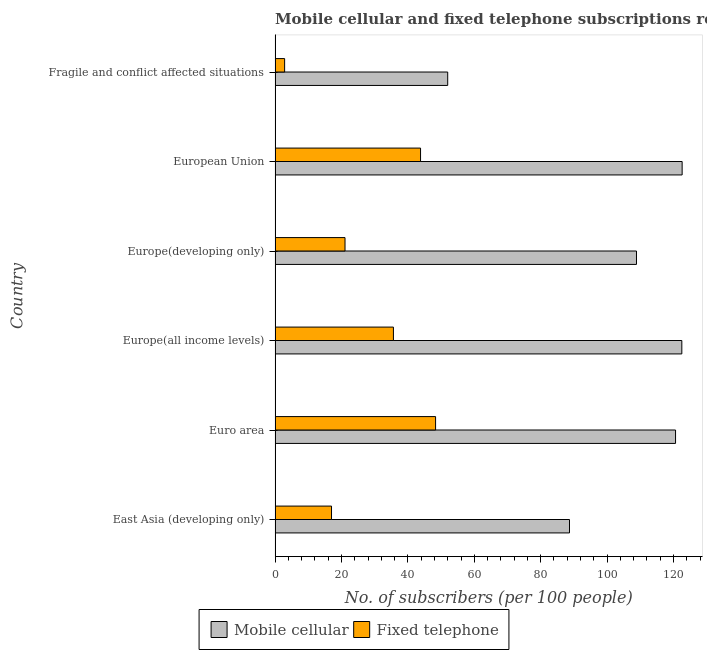Are the number of bars per tick equal to the number of legend labels?
Offer a terse response. Yes. How many bars are there on the 1st tick from the top?
Offer a very short reply. 2. What is the label of the 1st group of bars from the top?
Offer a terse response. Fragile and conflict affected situations. In how many cases, is the number of bars for a given country not equal to the number of legend labels?
Offer a very short reply. 0. What is the number of fixed telephone subscribers in Europe(developing only)?
Your answer should be very brief. 21.07. Across all countries, what is the maximum number of mobile cellular subscribers?
Offer a terse response. 122.61. Across all countries, what is the minimum number of mobile cellular subscribers?
Provide a short and direct response. 51.99. In which country was the number of mobile cellular subscribers minimum?
Your response must be concise. Fragile and conflict affected situations. What is the total number of fixed telephone subscribers in the graph?
Ensure brevity in your answer.  168.74. What is the difference between the number of fixed telephone subscribers in East Asia (developing only) and that in European Union?
Keep it short and to the point. -26.82. What is the difference between the number of mobile cellular subscribers in Euro area and the number of fixed telephone subscribers in East Asia (developing only)?
Make the answer very short. 103.62. What is the average number of mobile cellular subscribers per country?
Offer a terse response. 102.55. What is the difference between the number of fixed telephone subscribers and number of mobile cellular subscribers in Europe(all income levels)?
Provide a succinct answer. -86.87. What is the ratio of the number of mobile cellular subscribers in East Asia (developing only) to that in Europe(all income levels)?
Provide a succinct answer. 0.72. Is the number of mobile cellular subscribers in Europe(developing only) less than that in European Union?
Provide a succinct answer. Yes. Is the difference between the number of fixed telephone subscribers in Europe(all income levels) and Europe(developing only) greater than the difference between the number of mobile cellular subscribers in Europe(all income levels) and Europe(developing only)?
Your response must be concise. Yes. What is the difference between the highest and the second highest number of fixed telephone subscribers?
Your response must be concise. 4.52. What is the difference between the highest and the lowest number of mobile cellular subscribers?
Offer a terse response. 70.62. In how many countries, is the number of mobile cellular subscribers greater than the average number of mobile cellular subscribers taken over all countries?
Give a very brief answer. 4. What does the 2nd bar from the top in European Union represents?
Ensure brevity in your answer.  Mobile cellular. What does the 2nd bar from the bottom in Euro area represents?
Ensure brevity in your answer.  Fixed telephone. How many bars are there?
Provide a succinct answer. 12. Are all the bars in the graph horizontal?
Ensure brevity in your answer.  Yes. How many countries are there in the graph?
Your answer should be very brief. 6. Are the values on the major ticks of X-axis written in scientific E-notation?
Your answer should be very brief. No. Does the graph contain any zero values?
Provide a short and direct response. No. Does the graph contain grids?
Offer a terse response. No. How many legend labels are there?
Your answer should be compact. 2. How are the legend labels stacked?
Make the answer very short. Horizontal. What is the title of the graph?
Make the answer very short. Mobile cellular and fixed telephone subscriptions recorded in 2012. What is the label or title of the X-axis?
Your response must be concise. No. of subscribers (per 100 people). What is the No. of subscribers (per 100 people) of Mobile cellular in East Asia (developing only)?
Provide a short and direct response. 88.68. What is the No. of subscribers (per 100 people) in Fixed telephone in East Asia (developing only)?
Give a very brief answer. 17. What is the No. of subscribers (per 100 people) of Mobile cellular in Euro area?
Provide a succinct answer. 120.63. What is the No. of subscribers (per 100 people) in Fixed telephone in Euro area?
Give a very brief answer. 48.34. What is the No. of subscribers (per 100 people) in Mobile cellular in Europe(all income levels)?
Ensure brevity in your answer.  122.52. What is the No. of subscribers (per 100 people) in Fixed telephone in Europe(all income levels)?
Make the answer very short. 35.65. What is the No. of subscribers (per 100 people) in Mobile cellular in Europe(developing only)?
Provide a short and direct response. 108.86. What is the No. of subscribers (per 100 people) in Fixed telephone in Europe(developing only)?
Offer a very short reply. 21.07. What is the No. of subscribers (per 100 people) of Mobile cellular in European Union?
Your answer should be very brief. 122.61. What is the No. of subscribers (per 100 people) of Fixed telephone in European Union?
Offer a very short reply. 43.82. What is the No. of subscribers (per 100 people) in Mobile cellular in Fragile and conflict affected situations?
Provide a short and direct response. 51.99. What is the No. of subscribers (per 100 people) of Fixed telephone in Fragile and conflict affected situations?
Ensure brevity in your answer.  2.87. Across all countries, what is the maximum No. of subscribers (per 100 people) in Mobile cellular?
Keep it short and to the point. 122.61. Across all countries, what is the maximum No. of subscribers (per 100 people) in Fixed telephone?
Give a very brief answer. 48.34. Across all countries, what is the minimum No. of subscribers (per 100 people) in Mobile cellular?
Provide a succinct answer. 51.99. Across all countries, what is the minimum No. of subscribers (per 100 people) of Fixed telephone?
Keep it short and to the point. 2.87. What is the total No. of subscribers (per 100 people) in Mobile cellular in the graph?
Provide a succinct answer. 615.29. What is the total No. of subscribers (per 100 people) in Fixed telephone in the graph?
Your response must be concise. 168.75. What is the difference between the No. of subscribers (per 100 people) in Mobile cellular in East Asia (developing only) and that in Euro area?
Provide a succinct answer. -31.94. What is the difference between the No. of subscribers (per 100 people) in Fixed telephone in East Asia (developing only) and that in Euro area?
Keep it short and to the point. -31.34. What is the difference between the No. of subscribers (per 100 people) in Mobile cellular in East Asia (developing only) and that in Europe(all income levels)?
Make the answer very short. -33.84. What is the difference between the No. of subscribers (per 100 people) of Fixed telephone in East Asia (developing only) and that in Europe(all income levels)?
Your answer should be compact. -18.65. What is the difference between the No. of subscribers (per 100 people) of Mobile cellular in East Asia (developing only) and that in Europe(developing only)?
Keep it short and to the point. -20.18. What is the difference between the No. of subscribers (per 100 people) of Fixed telephone in East Asia (developing only) and that in Europe(developing only)?
Your answer should be compact. -4.06. What is the difference between the No. of subscribers (per 100 people) in Mobile cellular in East Asia (developing only) and that in European Union?
Your response must be concise. -33.93. What is the difference between the No. of subscribers (per 100 people) of Fixed telephone in East Asia (developing only) and that in European Union?
Give a very brief answer. -26.82. What is the difference between the No. of subscribers (per 100 people) in Mobile cellular in East Asia (developing only) and that in Fragile and conflict affected situations?
Offer a terse response. 36.69. What is the difference between the No. of subscribers (per 100 people) in Fixed telephone in East Asia (developing only) and that in Fragile and conflict affected situations?
Ensure brevity in your answer.  14.13. What is the difference between the No. of subscribers (per 100 people) in Mobile cellular in Euro area and that in Europe(all income levels)?
Give a very brief answer. -1.89. What is the difference between the No. of subscribers (per 100 people) of Fixed telephone in Euro area and that in Europe(all income levels)?
Your answer should be very brief. 12.7. What is the difference between the No. of subscribers (per 100 people) of Mobile cellular in Euro area and that in Europe(developing only)?
Provide a short and direct response. 11.77. What is the difference between the No. of subscribers (per 100 people) of Fixed telephone in Euro area and that in Europe(developing only)?
Make the answer very short. 27.28. What is the difference between the No. of subscribers (per 100 people) in Mobile cellular in Euro area and that in European Union?
Make the answer very short. -1.99. What is the difference between the No. of subscribers (per 100 people) of Fixed telephone in Euro area and that in European Union?
Ensure brevity in your answer.  4.52. What is the difference between the No. of subscribers (per 100 people) in Mobile cellular in Euro area and that in Fragile and conflict affected situations?
Make the answer very short. 68.63. What is the difference between the No. of subscribers (per 100 people) in Fixed telephone in Euro area and that in Fragile and conflict affected situations?
Ensure brevity in your answer.  45.47. What is the difference between the No. of subscribers (per 100 people) of Mobile cellular in Europe(all income levels) and that in Europe(developing only)?
Keep it short and to the point. 13.66. What is the difference between the No. of subscribers (per 100 people) of Fixed telephone in Europe(all income levels) and that in Europe(developing only)?
Give a very brief answer. 14.58. What is the difference between the No. of subscribers (per 100 people) in Mobile cellular in Europe(all income levels) and that in European Union?
Provide a short and direct response. -0.09. What is the difference between the No. of subscribers (per 100 people) in Fixed telephone in Europe(all income levels) and that in European Union?
Provide a succinct answer. -8.17. What is the difference between the No. of subscribers (per 100 people) of Mobile cellular in Europe(all income levels) and that in Fragile and conflict affected situations?
Your answer should be very brief. 70.52. What is the difference between the No. of subscribers (per 100 people) of Fixed telephone in Europe(all income levels) and that in Fragile and conflict affected situations?
Your response must be concise. 32.77. What is the difference between the No. of subscribers (per 100 people) in Mobile cellular in Europe(developing only) and that in European Union?
Offer a terse response. -13.75. What is the difference between the No. of subscribers (per 100 people) of Fixed telephone in Europe(developing only) and that in European Union?
Keep it short and to the point. -22.75. What is the difference between the No. of subscribers (per 100 people) in Mobile cellular in Europe(developing only) and that in Fragile and conflict affected situations?
Your answer should be compact. 56.86. What is the difference between the No. of subscribers (per 100 people) of Fixed telephone in Europe(developing only) and that in Fragile and conflict affected situations?
Offer a very short reply. 18.19. What is the difference between the No. of subscribers (per 100 people) of Mobile cellular in European Union and that in Fragile and conflict affected situations?
Provide a short and direct response. 70.62. What is the difference between the No. of subscribers (per 100 people) of Fixed telephone in European Union and that in Fragile and conflict affected situations?
Your answer should be very brief. 40.94. What is the difference between the No. of subscribers (per 100 people) of Mobile cellular in East Asia (developing only) and the No. of subscribers (per 100 people) of Fixed telephone in Euro area?
Keep it short and to the point. 40.34. What is the difference between the No. of subscribers (per 100 people) of Mobile cellular in East Asia (developing only) and the No. of subscribers (per 100 people) of Fixed telephone in Europe(all income levels)?
Offer a terse response. 53.03. What is the difference between the No. of subscribers (per 100 people) in Mobile cellular in East Asia (developing only) and the No. of subscribers (per 100 people) in Fixed telephone in Europe(developing only)?
Provide a succinct answer. 67.62. What is the difference between the No. of subscribers (per 100 people) of Mobile cellular in East Asia (developing only) and the No. of subscribers (per 100 people) of Fixed telephone in European Union?
Keep it short and to the point. 44.86. What is the difference between the No. of subscribers (per 100 people) of Mobile cellular in East Asia (developing only) and the No. of subscribers (per 100 people) of Fixed telephone in Fragile and conflict affected situations?
Make the answer very short. 85.81. What is the difference between the No. of subscribers (per 100 people) in Mobile cellular in Euro area and the No. of subscribers (per 100 people) in Fixed telephone in Europe(all income levels)?
Provide a succinct answer. 84.98. What is the difference between the No. of subscribers (per 100 people) in Mobile cellular in Euro area and the No. of subscribers (per 100 people) in Fixed telephone in Europe(developing only)?
Give a very brief answer. 99.56. What is the difference between the No. of subscribers (per 100 people) in Mobile cellular in Euro area and the No. of subscribers (per 100 people) in Fixed telephone in European Union?
Make the answer very short. 76.81. What is the difference between the No. of subscribers (per 100 people) of Mobile cellular in Euro area and the No. of subscribers (per 100 people) of Fixed telephone in Fragile and conflict affected situations?
Provide a short and direct response. 117.75. What is the difference between the No. of subscribers (per 100 people) in Mobile cellular in Europe(all income levels) and the No. of subscribers (per 100 people) in Fixed telephone in Europe(developing only)?
Your response must be concise. 101.45. What is the difference between the No. of subscribers (per 100 people) of Mobile cellular in Europe(all income levels) and the No. of subscribers (per 100 people) of Fixed telephone in European Union?
Offer a very short reply. 78.7. What is the difference between the No. of subscribers (per 100 people) in Mobile cellular in Europe(all income levels) and the No. of subscribers (per 100 people) in Fixed telephone in Fragile and conflict affected situations?
Provide a succinct answer. 119.64. What is the difference between the No. of subscribers (per 100 people) in Mobile cellular in Europe(developing only) and the No. of subscribers (per 100 people) in Fixed telephone in European Union?
Offer a terse response. 65.04. What is the difference between the No. of subscribers (per 100 people) in Mobile cellular in Europe(developing only) and the No. of subscribers (per 100 people) in Fixed telephone in Fragile and conflict affected situations?
Provide a short and direct response. 105.98. What is the difference between the No. of subscribers (per 100 people) in Mobile cellular in European Union and the No. of subscribers (per 100 people) in Fixed telephone in Fragile and conflict affected situations?
Make the answer very short. 119.74. What is the average No. of subscribers (per 100 people) in Mobile cellular per country?
Make the answer very short. 102.55. What is the average No. of subscribers (per 100 people) in Fixed telephone per country?
Make the answer very short. 28.12. What is the difference between the No. of subscribers (per 100 people) in Mobile cellular and No. of subscribers (per 100 people) in Fixed telephone in East Asia (developing only)?
Your response must be concise. 71.68. What is the difference between the No. of subscribers (per 100 people) in Mobile cellular and No. of subscribers (per 100 people) in Fixed telephone in Euro area?
Offer a terse response. 72.28. What is the difference between the No. of subscribers (per 100 people) in Mobile cellular and No. of subscribers (per 100 people) in Fixed telephone in Europe(all income levels)?
Offer a very short reply. 86.87. What is the difference between the No. of subscribers (per 100 people) of Mobile cellular and No. of subscribers (per 100 people) of Fixed telephone in Europe(developing only)?
Offer a terse response. 87.79. What is the difference between the No. of subscribers (per 100 people) in Mobile cellular and No. of subscribers (per 100 people) in Fixed telephone in European Union?
Provide a succinct answer. 78.79. What is the difference between the No. of subscribers (per 100 people) in Mobile cellular and No. of subscribers (per 100 people) in Fixed telephone in Fragile and conflict affected situations?
Offer a terse response. 49.12. What is the ratio of the No. of subscribers (per 100 people) of Mobile cellular in East Asia (developing only) to that in Euro area?
Your answer should be very brief. 0.74. What is the ratio of the No. of subscribers (per 100 people) in Fixed telephone in East Asia (developing only) to that in Euro area?
Provide a succinct answer. 0.35. What is the ratio of the No. of subscribers (per 100 people) in Mobile cellular in East Asia (developing only) to that in Europe(all income levels)?
Keep it short and to the point. 0.72. What is the ratio of the No. of subscribers (per 100 people) of Fixed telephone in East Asia (developing only) to that in Europe(all income levels)?
Provide a succinct answer. 0.48. What is the ratio of the No. of subscribers (per 100 people) in Mobile cellular in East Asia (developing only) to that in Europe(developing only)?
Your answer should be very brief. 0.81. What is the ratio of the No. of subscribers (per 100 people) in Fixed telephone in East Asia (developing only) to that in Europe(developing only)?
Ensure brevity in your answer.  0.81. What is the ratio of the No. of subscribers (per 100 people) of Mobile cellular in East Asia (developing only) to that in European Union?
Your answer should be very brief. 0.72. What is the ratio of the No. of subscribers (per 100 people) in Fixed telephone in East Asia (developing only) to that in European Union?
Keep it short and to the point. 0.39. What is the ratio of the No. of subscribers (per 100 people) of Mobile cellular in East Asia (developing only) to that in Fragile and conflict affected situations?
Make the answer very short. 1.71. What is the ratio of the No. of subscribers (per 100 people) of Fixed telephone in East Asia (developing only) to that in Fragile and conflict affected situations?
Provide a succinct answer. 5.92. What is the ratio of the No. of subscribers (per 100 people) in Mobile cellular in Euro area to that in Europe(all income levels)?
Your answer should be compact. 0.98. What is the ratio of the No. of subscribers (per 100 people) of Fixed telephone in Euro area to that in Europe(all income levels)?
Give a very brief answer. 1.36. What is the ratio of the No. of subscribers (per 100 people) of Mobile cellular in Euro area to that in Europe(developing only)?
Provide a short and direct response. 1.11. What is the ratio of the No. of subscribers (per 100 people) in Fixed telephone in Euro area to that in Europe(developing only)?
Provide a succinct answer. 2.29. What is the ratio of the No. of subscribers (per 100 people) of Mobile cellular in Euro area to that in European Union?
Make the answer very short. 0.98. What is the ratio of the No. of subscribers (per 100 people) in Fixed telephone in Euro area to that in European Union?
Give a very brief answer. 1.1. What is the ratio of the No. of subscribers (per 100 people) of Mobile cellular in Euro area to that in Fragile and conflict affected situations?
Offer a very short reply. 2.32. What is the ratio of the No. of subscribers (per 100 people) in Fixed telephone in Euro area to that in Fragile and conflict affected situations?
Give a very brief answer. 16.82. What is the ratio of the No. of subscribers (per 100 people) in Mobile cellular in Europe(all income levels) to that in Europe(developing only)?
Your response must be concise. 1.13. What is the ratio of the No. of subscribers (per 100 people) in Fixed telephone in Europe(all income levels) to that in Europe(developing only)?
Make the answer very short. 1.69. What is the ratio of the No. of subscribers (per 100 people) in Mobile cellular in Europe(all income levels) to that in European Union?
Provide a succinct answer. 1. What is the ratio of the No. of subscribers (per 100 people) in Fixed telephone in Europe(all income levels) to that in European Union?
Make the answer very short. 0.81. What is the ratio of the No. of subscribers (per 100 people) in Mobile cellular in Europe(all income levels) to that in Fragile and conflict affected situations?
Ensure brevity in your answer.  2.36. What is the ratio of the No. of subscribers (per 100 people) of Fixed telephone in Europe(all income levels) to that in Fragile and conflict affected situations?
Your answer should be very brief. 12.4. What is the ratio of the No. of subscribers (per 100 people) in Mobile cellular in Europe(developing only) to that in European Union?
Provide a succinct answer. 0.89. What is the ratio of the No. of subscribers (per 100 people) of Fixed telephone in Europe(developing only) to that in European Union?
Give a very brief answer. 0.48. What is the ratio of the No. of subscribers (per 100 people) in Mobile cellular in Europe(developing only) to that in Fragile and conflict affected situations?
Keep it short and to the point. 2.09. What is the ratio of the No. of subscribers (per 100 people) in Fixed telephone in Europe(developing only) to that in Fragile and conflict affected situations?
Provide a short and direct response. 7.33. What is the ratio of the No. of subscribers (per 100 people) of Mobile cellular in European Union to that in Fragile and conflict affected situations?
Ensure brevity in your answer.  2.36. What is the ratio of the No. of subscribers (per 100 people) of Fixed telephone in European Union to that in Fragile and conflict affected situations?
Provide a succinct answer. 15.25. What is the difference between the highest and the second highest No. of subscribers (per 100 people) of Mobile cellular?
Your answer should be very brief. 0.09. What is the difference between the highest and the second highest No. of subscribers (per 100 people) in Fixed telephone?
Provide a succinct answer. 4.52. What is the difference between the highest and the lowest No. of subscribers (per 100 people) of Mobile cellular?
Offer a terse response. 70.62. What is the difference between the highest and the lowest No. of subscribers (per 100 people) of Fixed telephone?
Offer a terse response. 45.47. 